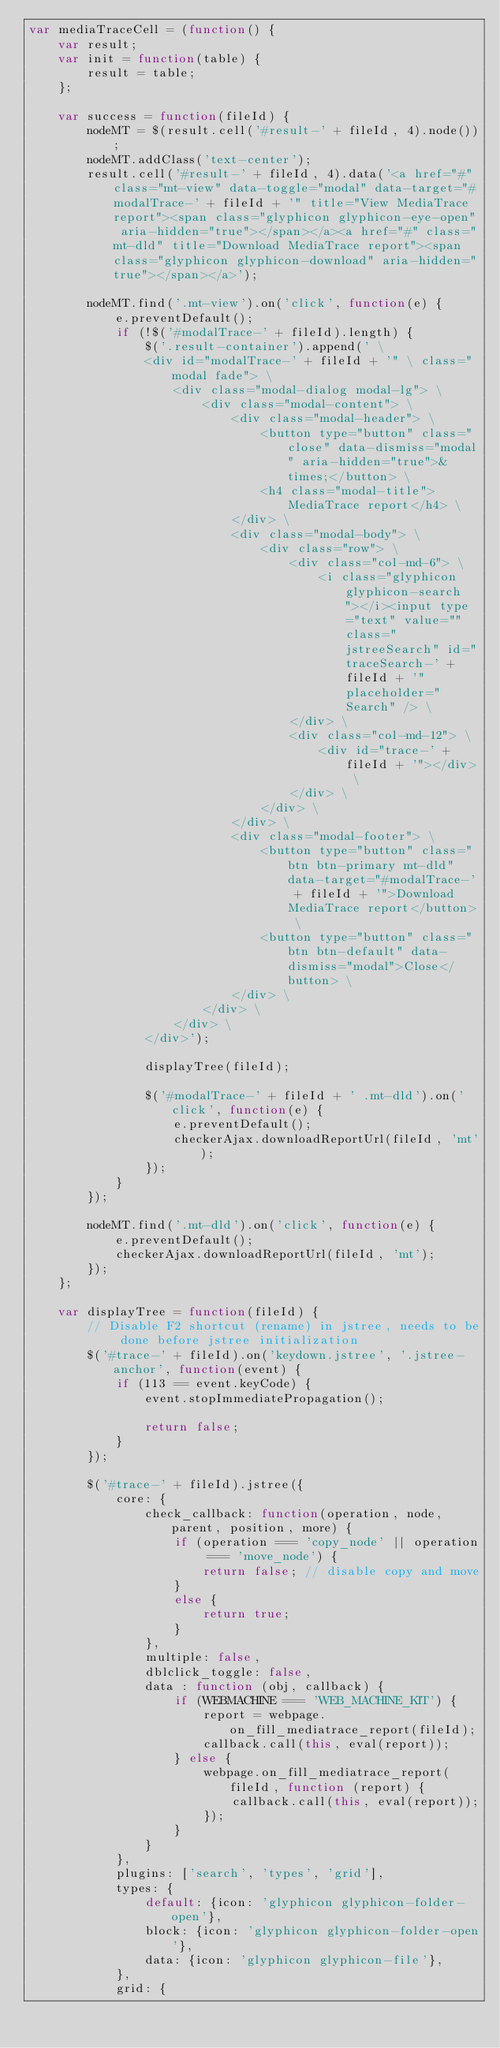<code> <loc_0><loc_0><loc_500><loc_500><_JavaScript_>var mediaTraceCell = (function() {
    var result;
    var init = function(table) {
        result = table;
    };

    var success = function(fileId) {
        nodeMT = $(result.cell('#result-' + fileId, 4).node());
        nodeMT.addClass('text-center');
        result.cell('#result-' + fileId, 4).data('<a href="#" class="mt-view" data-toggle="modal" data-target="#modalTrace-' + fileId + '" title="View MediaTrace report"><span class="glyphicon glyphicon-eye-open" aria-hidden="true"></span></a><a href="#" class="mt-dld" title="Download MediaTrace report"><span class="glyphicon glyphicon-download" aria-hidden="true"></span></a>');

        nodeMT.find('.mt-view').on('click', function(e) {
            e.preventDefault();
            if (!$('#modalTrace-' + fileId).length) {
                $('.result-container').append(' \
                <div id="modalTrace-' + fileId + '" \ class="modal fade"> \
                    <div class="modal-dialog modal-lg"> \
                        <div class="modal-content"> \
                            <div class="modal-header"> \
                                <button type="button" class="close" data-dismiss="modal" aria-hidden="true">&times;</button> \
                                <h4 class="modal-title">MediaTrace report</h4> \
                            </div> \
                            <div class="modal-body"> \
                                <div class="row"> \
                                    <div class="col-md-6"> \
                                        <i class="glyphicon glyphicon-search"></i><input type="text" value="" class="jstreeSearch" id="traceSearch-' + fileId + '" placeholder="Search" /> \
                                    </div> \
                                    <div class="col-md-12"> \
                                        <div id="trace-' + fileId + '"></div> \
                                    </div> \
                                </div> \
                            </div> \
                            <div class="modal-footer"> \
                                <button type="button" class="btn btn-primary mt-dld" data-target="#modalTrace-' + fileId + '">Download MediaTrace report</button> \
                                <button type="button" class="btn btn-default" data-dismiss="modal">Close</button> \
                            </div> \
                        </div> \
                    </div> \
                </div>');

                displayTree(fileId);

                $('#modalTrace-' + fileId + ' .mt-dld').on('click', function(e) {
                    e.preventDefault();
                    checkerAjax.downloadReportUrl(fileId, 'mt');
                });
            }
        });

        nodeMT.find('.mt-dld').on('click', function(e) {
            e.preventDefault();
            checkerAjax.downloadReportUrl(fileId, 'mt');
        });
    };

    var displayTree = function(fileId) {
        // Disable F2 shortcut (rename) in jstree, needs to be done before jstree initialization
        $('#trace-' + fileId).on('keydown.jstree', '.jstree-anchor', function(event) {
            if (113 == event.keyCode) {
                event.stopImmediatePropagation();

                return false;
            }
        });

        $('#trace-' + fileId).jstree({
            core: {
                check_callback: function(operation, node, parent, position, more) {
                    if (operation === 'copy_node' || operation === 'move_node') {
                        return false; // disable copy and move
                    }
                    else {
                        return true;
                    }
                },
                multiple: false,
                dblclick_toggle: false,
                data : function (obj, callback) {
                    if (WEBMACHINE === 'WEB_MACHINE_KIT') {
                        report = webpage.on_fill_mediatrace_report(fileId);
                        callback.call(this, eval(report));
                    } else {
                        webpage.on_fill_mediatrace_report(fileId, function (report) {
                            callback.call(this, eval(report));
                        });
                    }
                }
            },
            plugins: ['search', 'types', 'grid'],
            types: {
                default: {icon: 'glyphicon glyphicon-folder-open'},
                block: {icon: 'glyphicon glyphicon-folder-open'},
                data: {icon: 'glyphicon glyphicon-file'},
            },
            grid: {</code> 